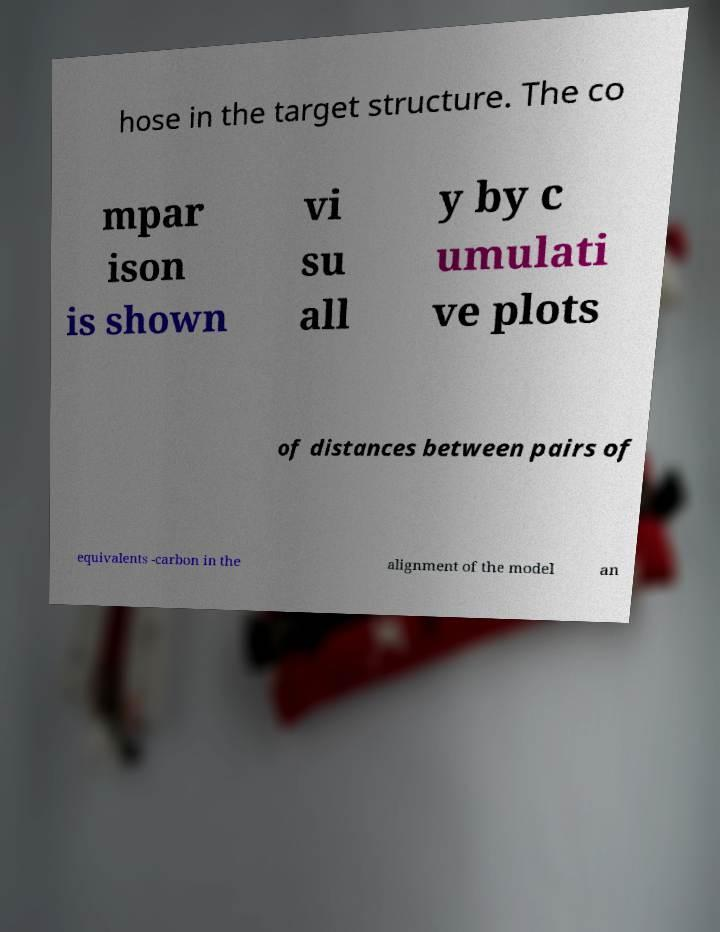I need the written content from this picture converted into text. Can you do that? hose in the target structure. The co mpar ison is shown vi su all y by c umulati ve plots of distances between pairs of equivalents -carbon in the alignment of the model an 